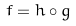<formula> <loc_0><loc_0><loc_500><loc_500>\bar { f } = h \circ g</formula> 